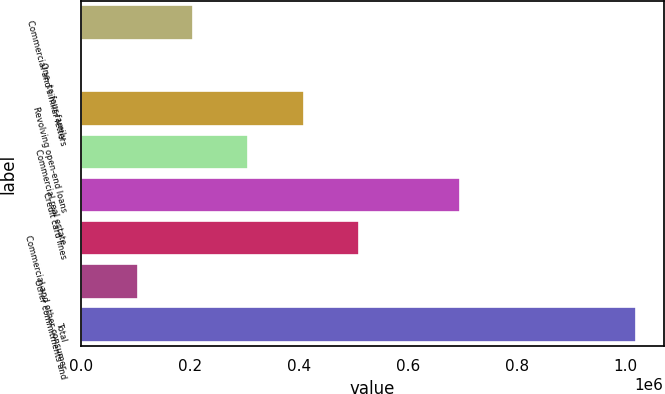Convert chart. <chart><loc_0><loc_0><loc_500><loc_500><bar_chart><fcel>Commercial and similar letters<fcel>One- to four-family<fcel>Revolving open-end loans<fcel>Commercial real estate<fcel>Credit card lines<fcel>Commercial and other consumer<fcel>Other commitments and<fcel>Total<nl><fcel>205916<fcel>2671<fcel>409160<fcel>307538<fcel>696007<fcel>510782<fcel>104293<fcel>1.01889e+06<nl></chart> 